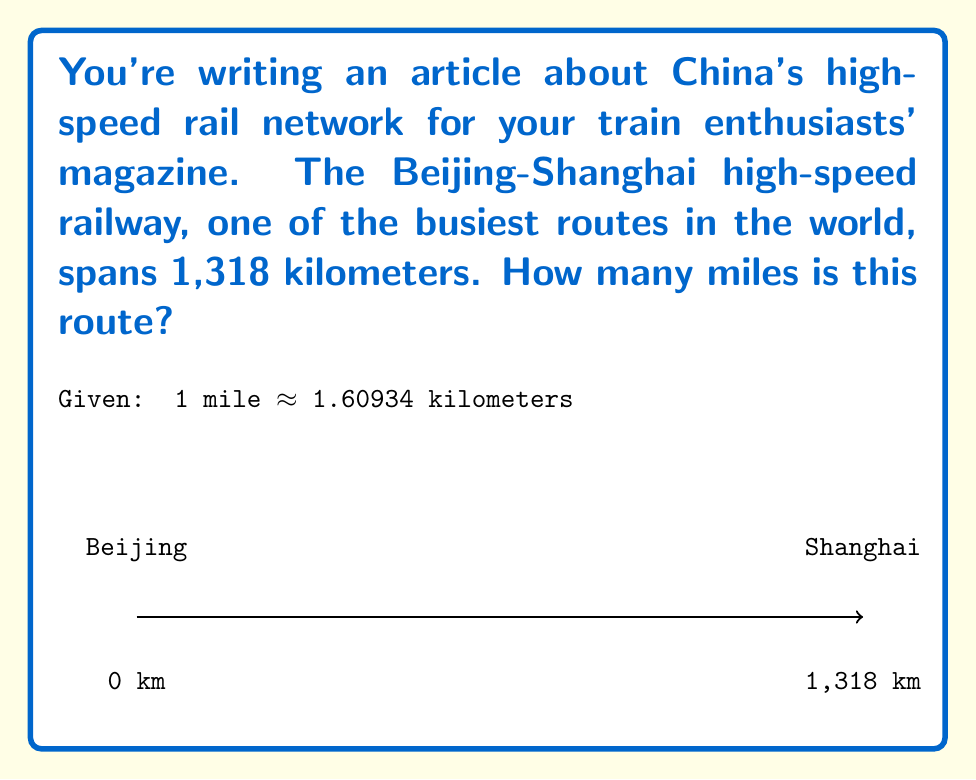Can you solve this math problem? To convert kilometers to miles, we need to divide the number of kilometers by the conversion factor:

1. Set up the conversion equation:
   $$ \text{miles} = \frac{\text{kilometers}}{1.60934} $$

2. Substitute the given distance:
   $$ \text{miles} = \frac{1,318}{1.60934} $$

3. Perform the division:
   $$ \text{miles} = 819.0043... $$

4. Round to the nearest whole number, as it's more practical for reporting distances in a magazine article:
   $$ \text{miles} \approx 819 $$

Therefore, the Beijing-Shanghai high-speed railway route is approximately 819 miles long.
Answer: 819 miles 